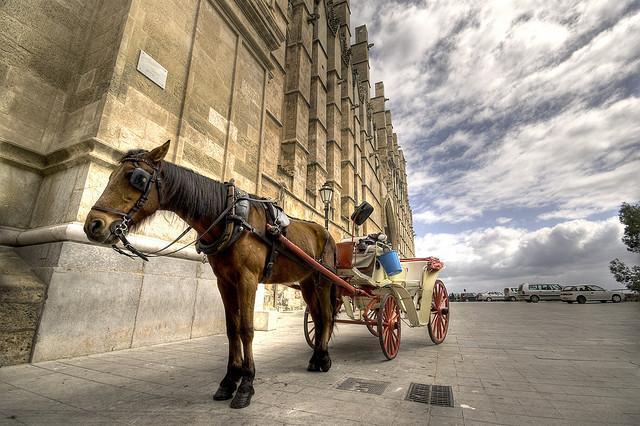This animal is most closely related to what other animal?
From the following four choices, select the correct answer to address the question.
Options: Mollusk, donkey, badger, possum. Donkey. 